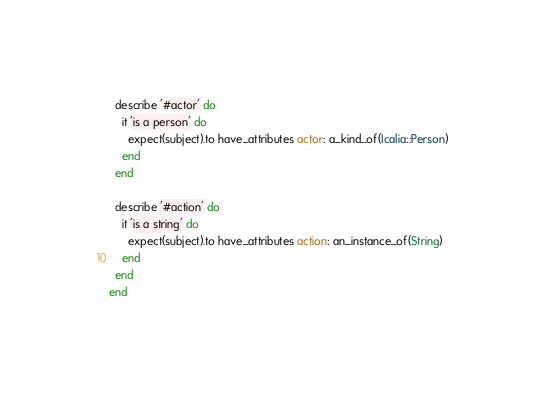<code> <loc_0><loc_0><loc_500><loc_500><_Ruby_>  describe '#actor' do
    it 'is a person' do
      expect(subject).to have_attributes actor: a_kind_of(Icalia::Person)
    end
  end

  describe '#action' do
    it 'is a string' do
      expect(subject).to have_attributes action: an_instance_of(String)
    end
  end
end
</code> 